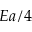<formula> <loc_0><loc_0><loc_500><loc_500>E a / 4</formula> 